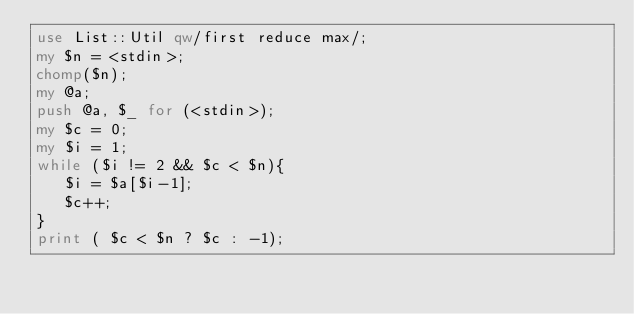Convert code to text. <code><loc_0><loc_0><loc_500><loc_500><_Perl_>use List::Util qw/first reduce max/;
my $n = <stdin>;
chomp($n);
my @a;
push @a, $_ for (<stdin>);
my $c = 0;
my $i = 1;
while ($i != 2 && $c < $n){
   $i = $a[$i-1];
   $c++;
}
print ( $c < $n ? $c : -1);</code> 